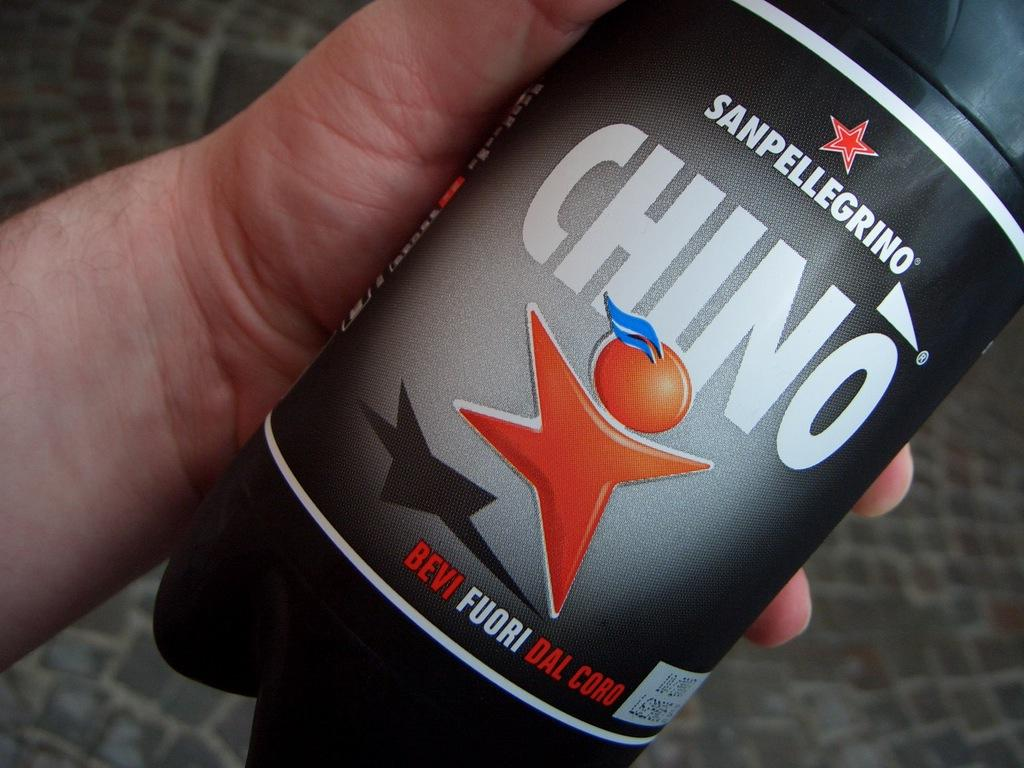<image>
Give a short and clear explanation of the subsequent image. Someone holding a bottle of San Pellegrino Chino in their hand. 